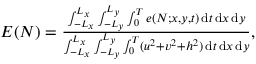Convert formula to latex. <formula><loc_0><loc_0><loc_500><loc_500>\begin{array} { r } { E ( N ) = \frac { \int _ { - L _ { x } } ^ { L _ { x } } \int _ { - L _ { y } } ^ { L _ { y } } \int _ { 0 } ^ { T } e ( N ; x , y , t ) \, d t \, d x \, d y } { \int _ { - L _ { x } } ^ { L _ { x } } \int _ { - L _ { y } } ^ { L _ { y } } \int _ { 0 } ^ { T } ( u ^ { 2 } + v ^ { 2 } + h ^ { 2 } ) \, d t \, d x \, d y } , } \end{array}</formula> 